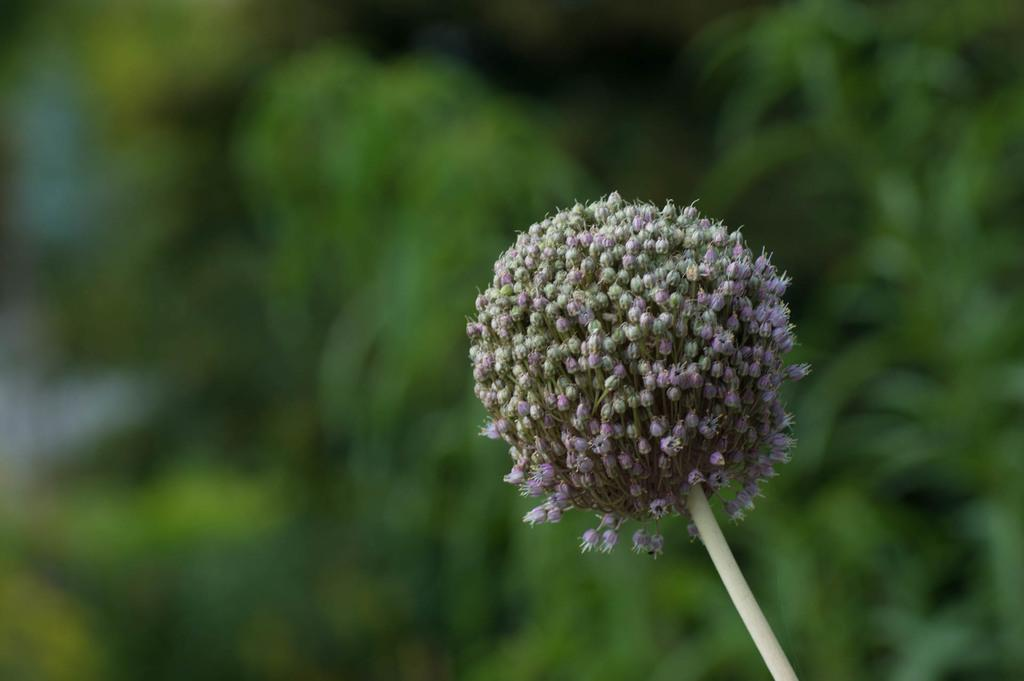What type of plants can be seen in the image? There are tiny flowers in the image. What stage of growth are the flowers in? The flowers are in the bud stage. What color is the background of the image? The background of the image is greenish and blurred. How many slaves are visible in the image? There are no slaves present in the image; it features tiny flowers in the bud stage with a greenish and blurred background. 